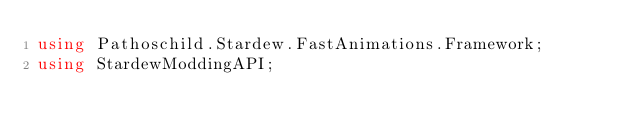<code> <loc_0><loc_0><loc_500><loc_500><_C#_>using Pathoschild.Stardew.FastAnimations.Framework;
using StardewModdingAPI;</code> 